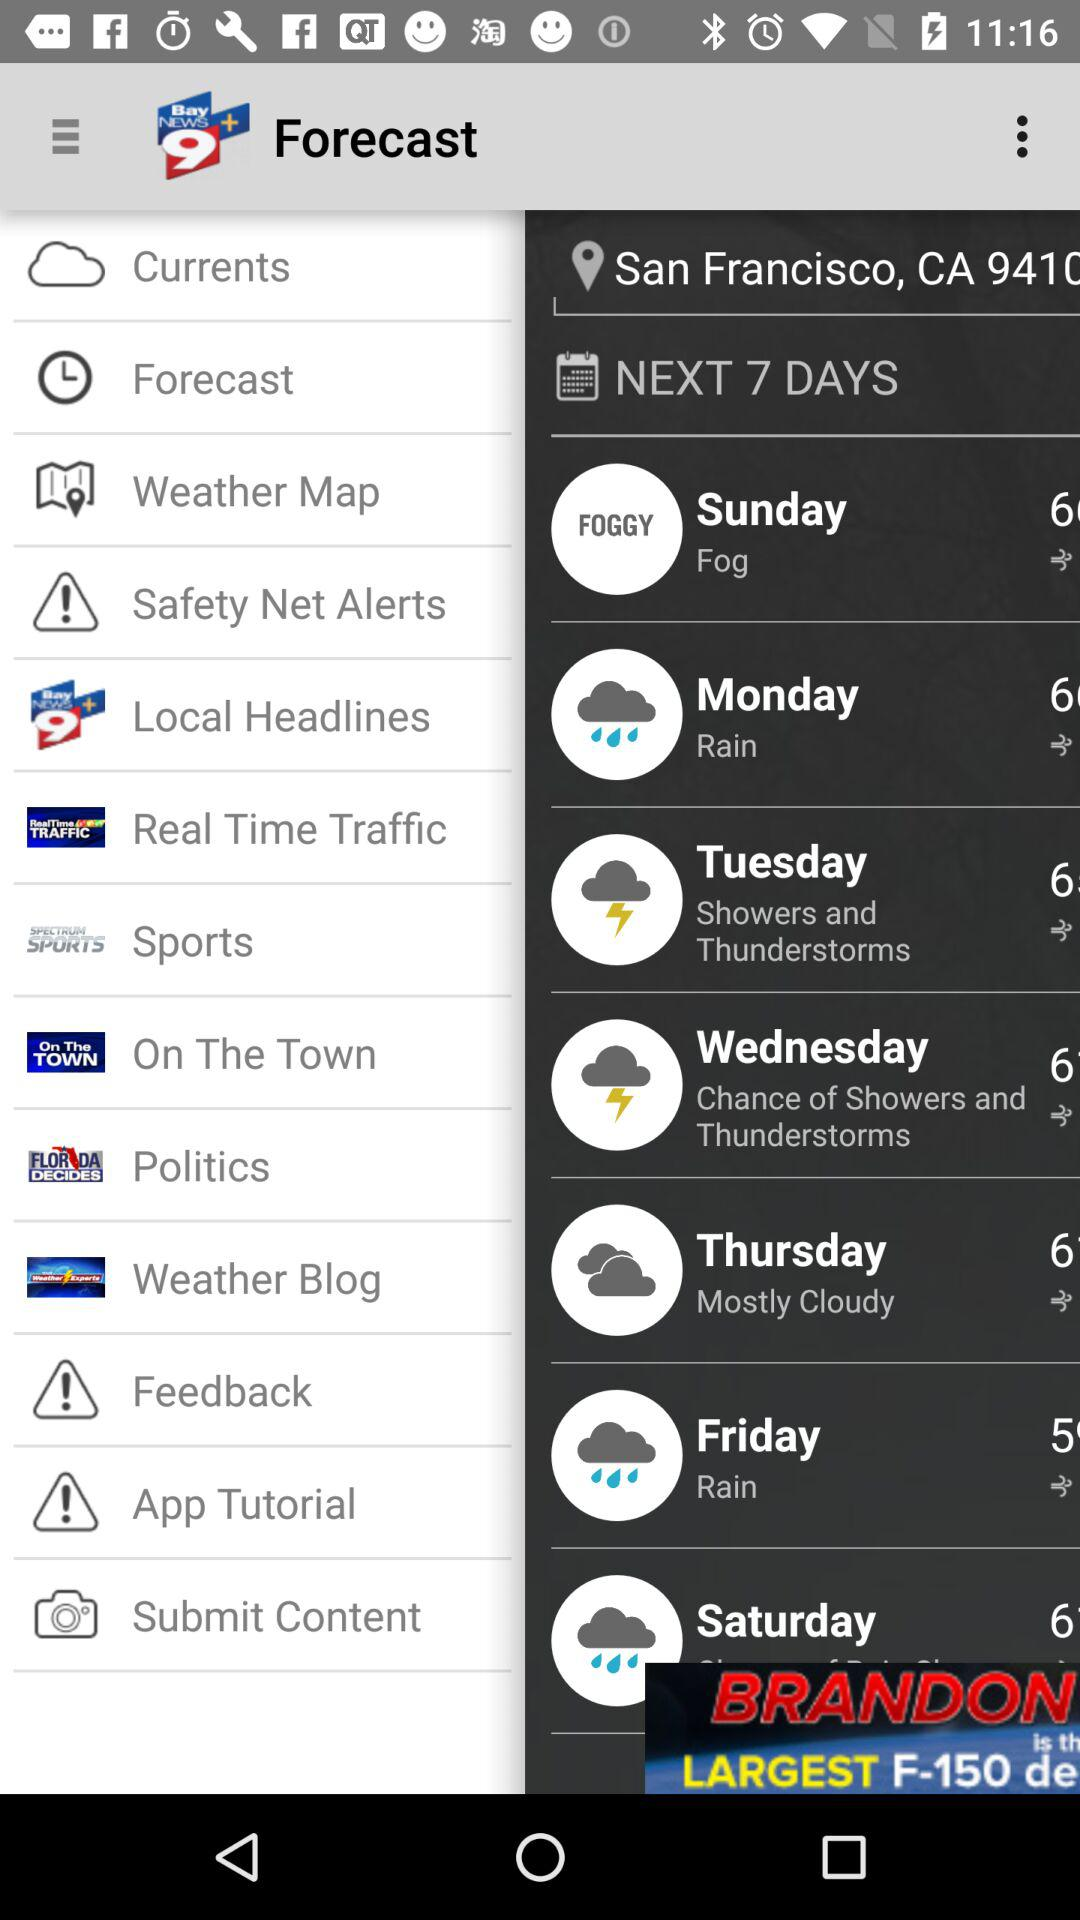How many days are shown on the screen? There are 7 days shown on the screen. 